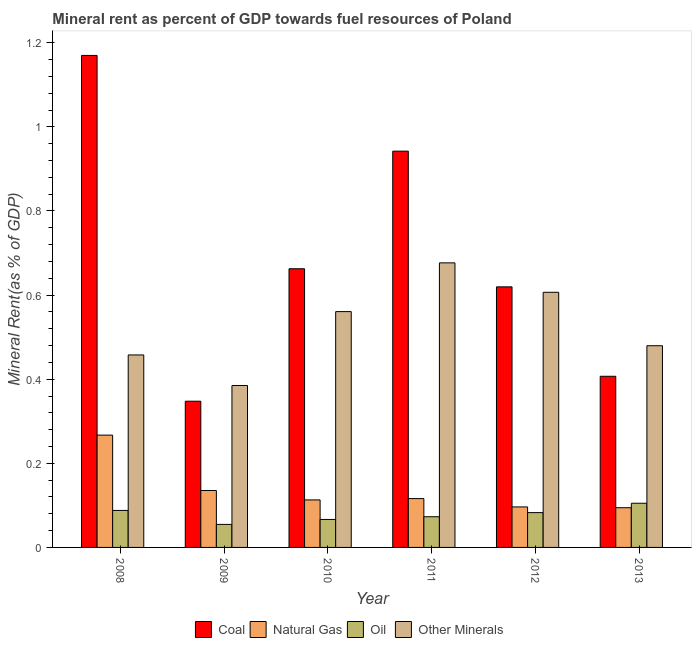How many groups of bars are there?
Provide a short and direct response. 6. Are the number of bars per tick equal to the number of legend labels?
Your answer should be very brief. Yes. What is the label of the 2nd group of bars from the left?
Ensure brevity in your answer.  2009. In how many cases, is the number of bars for a given year not equal to the number of legend labels?
Offer a very short reply. 0. What is the natural gas rent in 2009?
Make the answer very short. 0.14. Across all years, what is the maximum natural gas rent?
Keep it short and to the point. 0.27. Across all years, what is the minimum  rent of other minerals?
Provide a short and direct response. 0.39. In which year was the coal rent maximum?
Provide a short and direct response. 2008. In which year was the coal rent minimum?
Your answer should be very brief. 2009. What is the total coal rent in the graph?
Provide a short and direct response. 4.15. What is the difference between the natural gas rent in 2008 and that in 2010?
Provide a succinct answer. 0.15. What is the difference between the  rent of other minerals in 2008 and the oil rent in 2010?
Offer a terse response. -0.1. What is the average oil rent per year?
Provide a succinct answer. 0.08. In how many years, is the coal rent greater than 0.56 %?
Your answer should be compact. 4. What is the ratio of the natural gas rent in 2008 to that in 2012?
Give a very brief answer. 2.77. Is the difference between the oil rent in 2008 and 2013 greater than the difference between the coal rent in 2008 and 2013?
Offer a very short reply. No. What is the difference between the highest and the second highest  rent of other minerals?
Your answer should be very brief. 0.07. What is the difference between the highest and the lowest coal rent?
Provide a succinct answer. 0.82. What does the 4th bar from the left in 2013 represents?
Offer a very short reply. Other Minerals. What does the 4th bar from the right in 2013 represents?
Your answer should be very brief. Coal. Is it the case that in every year, the sum of the coal rent and natural gas rent is greater than the oil rent?
Keep it short and to the point. Yes. How many bars are there?
Make the answer very short. 24. Are all the bars in the graph horizontal?
Make the answer very short. No. Are the values on the major ticks of Y-axis written in scientific E-notation?
Your answer should be very brief. No. Does the graph contain any zero values?
Provide a succinct answer. No. Does the graph contain grids?
Keep it short and to the point. No. How many legend labels are there?
Your answer should be very brief. 4. What is the title of the graph?
Offer a terse response. Mineral rent as percent of GDP towards fuel resources of Poland. Does "Plant species" appear as one of the legend labels in the graph?
Provide a succinct answer. No. What is the label or title of the X-axis?
Ensure brevity in your answer.  Year. What is the label or title of the Y-axis?
Make the answer very short. Mineral Rent(as % of GDP). What is the Mineral Rent(as % of GDP) of Coal in 2008?
Your answer should be very brief. 1.17. What is the Mineral Rent(as % of GDP) of Natural Gas in 2008?
Ensure brevity in your answer.  0.27. What is the Mineral Rent(as % of GDP) in Oil in 2008?
Keep it short and to the point. 0.09. What is the Mineral Rent(as % of GDP) of Other Minerals in 2008?
Offer a very short reply. 0.46. What is the Mineral Rent(as % of GDP) of Coal in 2009?
Your answer should be compact. 0.35. What is the Mineral Rent(as % of GDP) of Natural Gas in 2009?
Ensure brevity in your answer.  0.14. What is the Mineral Rent(as % of GDP) of Oil in 2009?
Provide a succinct answer. 0.05. What is the Mineral Rent(as % of GDP) of Other Minerals in 2009?
Keep it short and to the point. 0.39. What is the Mineral Rent(as % of GDP) in Coal in 2010?
Your answer should be compact. 0.66. What is the Mineral Rent(as % of GDP) of Natural Gas in 2010?
Ensure brevity in your answer.  0.11. What is the Mineral Rent(as % of GDP) in Oil in 2010?
Provide a short and direct response. 0.07. What is the Mineral Rent(as % of GDP) of Other Minerals in 2010?
Your answer should be compact. 0.56. What is the Mineral Rent(as % of GDP) of Coal in 2011?
Ensure brevity in your answer.  0.94. What is the Mineral Rent(as % of GDP) in Natural Gas in 2011?
Provide a short and direct response. 0.12. What is the Mineral Rent(as % of GDP) in Oil in 2011?
Your response must be concise. 0.07. What is the Mineral Rent(as % of GDP) of Other Minerals in 2011?
Your answer should be very brief. 0.68. What is the Mineral Rent(as % of GDP) of Coal in 2012?
Your answer should be very brief. 0.62. What is the Mineral Rent(as % of GDP) of Natural Gas in 2012?
Your response must be concise. 0.1. What is the Mineral Rent(as % of GDP) in Oil in 2012?
Your response must be concise. 0.08. What is the Mineral Rent(as % of GDP) in Other Minerals in 2012?
Make the answer very short. 0.61. What is the Mineral Rent(as % of GDP) of Coal in 2013?
Offer a very short reply. 0.41. What is the Mineral Rent(as % of GDP) in Natural Gas in 2013?
Give a very brief answer. 0.09. What is the Mineral Rent(as % of GDP) in Oil in 2013?
Your answer should be very brief. 0.11. What is the Mineral Rent(as % of GDP) in Other Minerals in 2013?
Give a very brief answer. 0.48. Across all years, what is the maximum Mineral Rent(as % of GDP) in Coal?
Keep it short and to the point. 1.17. Across all years, what is the maximum Mineral Rent(as % of GDP) in Natural Gas?
Your answer should be compact. 0.27. Across all years, what is the maximum Mineral Rent(as % of GDP) in Oil?
Provide a short and direct response. 0.11. Across all years, what is the maximum Mineral Rent(as % of GDP) in Other Minerals?
Your answer should be compact. 0.68. Across all years, what is the minimum Mineral Rent(as % of GDP) in Coal?
Ensure brevity in your answer.  0.35. Across all years, what is the minimum Mineral Rent(as % of GDP) in Natural Gas?
Ensure brevity in your answer.  0.09. Across all years, what is the minimum Mineral Rent(as % of GDP) of Oil?
Make the answer very short. 0.05. Across all years, what is the minimum Mineral Rent(as % of GDP) of Other Minerals?
Provide a succinct answer. 0.39. What is the total Mineral Rent(as % of GDP) in Coal in the graph?
Ensure brevity in your answer.  4.15. What is the total Mineral Rent(as % of GDP) in Natural Gas in the graph?
Provide a short and direct response. 0.82. What is the total Mineral Rent(as % of GDP) in Oil in the graph?
Your answer should be very brief. 0.47. What is the total Mineral Rent(as % of GDP) of Other Minerals in the graph?
Provide a succinct answer. 3.17. What is the difference between the Mineral Rent(as % of GDP) in Coal in 2008 and that in 2009?
Your answer should be compact. 0.82. What is the difference between the Mineral Rent(as % of GDP) of Natural Gas in 2008 and that in 2009?
Offer a terse response. 0.13. What is the difference between the Mineral Rent(as % of GDP) of Oil in 2008 and that in 2009?
Your answer should be very brief. 0.03. What is the difference between the Mineral Rent(as % of GDP) in Other Minerals in 2008 and that in 2009?
Ensure brevity in your answer.  0.07. What is the difference between the Mineral Rent(as % of GDP) in Coal in 2008 and that in 2010?
Ensure brevity in your answer.  0.51. What is the difference between the Mineral Rent(as % of GDP) of Natural Gas in 2008 and that in 2010?
Your response must be concise. 0.15. What is the difference between the Mineral Rent(as % of GDP) of Oil in 2008 and that in 2010?
Offer a very short reply. 0.02. What is the difference between the Mineral Rent(as % of GDP) in Other Minerals in 2008 and that in 2010?
Offer a very short reply. -0.1. What is the difference between the Mineral Rent(as % of GDP) in Coal in 2008 and that in 2011?
Your answer should be very brief. 0.23. What is the difference between the Mineral Rent(as % of GDP) of Natural Gas in 2008 and that in 2011?
Make the answer very short. 0.15. What is the difference between the Mineral Rent(as % of GDP) in Oil in 2008 and that in 2011?
Your answer should be compact. 0.01. What is the difference between the Mineral Rent(as % of GDP) of Other Minerals in 2008 and that in 2011?
Your response must be concise. -0.22. What is the difference between the Mineral Rent(as % of GDP) of Coal in 2008 and that in 2012?
Your response must be concise. 0.55. What is the difference between the Mineral Rent(as % of GDP) in Natural Gas in 2008 and that in 2012?
Your answer should be very brief. 0.17. What is the difference between the Mineral Rent(as % of GDP) of Oil in 2008 and that in 2012?
Offer a terse response. 0.01. What is the difference between the Mineral Rent(as % of GDP) in Other Minerals in 2008 and that in 2012?
Provide a short and direct response. -0.15. What is the difference between the Mineral Rent(as % of GDP) of Coal in 2008 and that in 2013?
Your answer should be compact. 0.76. What is the difference between the Mineral Rent(as % of GDP) of Natural Gas in 2008 and that in 2013?
Your answer should be compact. 0.17. What is the difference between the Mineral Rent(as % of GDP) in Oil in 2008 and that in 2013?
Provide a succinct answer. -0.02. What is the difference between the Mineral Rent(as % of GDP) in Other Minerals in 2008 and that in 2013?
Keep it short and to the point. -0.02. What is the difference between the Mineral Rent(as % of GDP) in Coal in 2009 and that in 2010?
Offer a very short reply. -0.32. What is the difference between the Mineral Rent(as % of GDP) of Natural Gas in 2009 and that in 2010?
Your response must be concise. 0.02. What is the difference between the Mineral Rent(as % of GDP) in Oil in 2009 and that in 2010?
Give a very brief answer. -0.01. What is the difference between the Mineral Rent(as % of GDP) in Other Minerals in 2009 and that in 2010?
Your answer should be compact. -0.18. What is the difference between the Mineral Rent(as % of GDP) of Coal in 2009 and that in 2011?
Your answer should be very brief. -0.59. What is the difference between the Mineral Rent(as % of GDP) in Natural Gas in 2009 and that in 2011?
Provide a short and direct response. 0.02. What is the difference between the Mineral Rent(as % of GDP) in Oil in 2009 and that in 2011?
Ensure brevity in your answer.  -0.02. What is the difference between the Mineral Rent(as % of GDP) of Other Minerals in 2009 and that in 2011?
Ensure brevity in your answer.  -0.29. What is the difference between the Mineral Rent(as % of GDP) in Coal in 2009 and that in 2012?
Your answer should be compact. -0.27. What is the difference between the Mineral Rent(as % of GDP) in Natural Gas in 2009 and that in 2012?
Your response must be concise. 0.04. What is the difference between the Mineral Rent(as % of GDP) in Oil in 2009 and that in 2012?
Give a very brief answer. -0.03. What is the difference between the Mineral Rent(as % of GDP) in Other Minerals in 2009 and that in 2012?
Offer a terse response. -0.22. What is the difference between the Mineral Rent(as % of GDP) in Coal in 2009 and that in 2013?
Offer a very short reply. -0.06. What is the difference between the Mineral Rent(as % of GDP) of Natural Gas in 2009 and that in 2013?
Ensure brevity in your answer.  0.04. What is the difference between the Mineral Rent(as % of GDP) in Oil in 2009 and that in 2013?
Make the answer very short. -0.05. What is the difference between the Mineral Rent(as % of GDP) of Other Minerals in 2009 and that in 2013?
Provide a succinct answer. -0.09. What is the difference between the Mineral Rent(as % of GDP) of Coal in 2010 and that in 2011?
Your answer should be very brief. -0.28. What is the difference between the Mineral Rent(as % of GDP) in Natural Gas in 2010 and that in 2011?
Offer a very short reply. -0. What is the difference between the Mineral Rent(as % of GDP) in Oil in 2010 and that in 2011?
Offer a terse response. -0.01. What is the difference between the Mineral Rent(as % of GDP) in Other Minerals in 2010 and that in 2011?
Your answer should be compact. -0.12. What is the difference between the Mineral Rent(as % of GDP) in Coal in 2010 and that in 2012?
Provide a succinct answer. 0.04. What is the difference between the Mineral Rent(as % of GDP) in Natural Gas in 2010 and that in 2012?
Provide a short and direct response. 0.02. What is the difference between the Mineral Rent(as % of GDP) of Oil in 2010 and that in 2012?
Keep it short and to the point. -0.02. What is the difference between the Mineral Rent(as % of GDP) in Other Minerals in 2010 and that in 2012?
Your answer should be compact. -0.05. What is the difference between the Mineral Rent(as % of GDP) of Coal in 2010 and that in 2013?
Provide a short and direct response. 0.26. What is the difference between the Mineral Rent(as % of GDP) of Natural Gas in 2010 and that in 2013?
Ensure brevity in your answer.  0.02. What is the difference between the Mineral Rent(as % of GDP) in Oil in 2010 and that in 2013?
Keep it short and to the point. -0.04. What is the difference between the Mineral Rent(as % of GDP) in Other Minerals in 2010 and that in 2013?
Your response must be concise. 0.08. What is the difference between the Mineral Rent(as % of GDP) of Coal in 2011 and that in 2012?
Your response must be concise. 0.32. What is the difference between the Mineral Rent(as % of GDP) of Natural Gas in 2011 and that in 2012?
Give a very brief answer. 0.02. What is the difference between the Mineral Rent(as % of GDP) in Oil in 2011 and that in 2012?
Offer a very short reply. -0.01. What is the difference between the Mineral Rent(as % of GDP) of Other Minerals in 2011 and that in 2012?
Your answer should be compact. 0.07. What is the difference between the Mineral Rent(as % of GDP) of Coal in 2011 and that in 2013?
Ensure brevity in your answer.  0.54. What is the difference between the Mineral Rent(as % of GDP) of Natural Gas in 2011 and that in 2013?
Provide a short and direct response. 0.02. What is the difference between the Mineral Rent(as % of GDP) in Oil in 2011 and that in 2013?
Your answer should be compact. -0.03. What is the difference between the Mineral Rent(as % of GDP) in Other Minerals in 2011 and that in 2013?
Keep it short and to the point. 0.2. What is the difference between the Mineral Rent(as % of GDP) in Coal in 2012 and that in 2013?
Provide a short and direct response. 0.21. What is the difference between the Mineral Rent(as % of GDP) in Natural Gas in 2012 and that in 2013?
Make the answer very short. 0. What is the difference between the Mineral Rent(as % of GDP) of Oil in 2012 and that in 2013?
Give a very brief answer. -0.02. What is the difference between the Mineral Rent(as % of GDP) of Other Minerals in 2012 and that in 2013?
Ensure brevity in your answer.  0.13. What is the difference between the Mineral Rent(as % of GDP) in Coal in 2008 and the Mineral Rent(as % of GDP) in Natural Gas in 2009?
Your answer should be compact. 1.03. What is the difference between the Mineral Rent(as % of GDP) in Coal in 2008 and the Mineral Rent(as % of GDP) in Oil in 2009?
Your answer should be very brief. 1.12. What is the difference between the Mineral Rent(as % of GDP) of Coal in 2008 and the Mineral Rent(as % of GDP) of Other Minerals in 2009?
Your answer should be very brief. 0.78. What is the difference between the Mineral Rent(as % of GDP) of Natural Gas in 2008 and the Mineral Rent(as % of GDP) of Oil in 2009?
Your answer should be very brief. 0.21. What is the difference between the Mineral Rent(as % of GDP) of Natural Gas in 2008 and the Mineral Rent(as % of GDP) of Other Minerals in 2009?
Your answer should be compact. -0.12. What is the difference between the Mineral Rent(as % of GDP) of Oil in 2008 and the Mineral Rent(as % of GDP) of Other Minerals in 2009?
Your answer should be very brief. -0.3. What is the difference between the Mineral Rent(as % of GDP) in Coal in 2008 and the Mineral Rent(as % of GDP) in Natural Gas in 2010?
Provide a short and direct response. 1.06. What is the difference between the Mineral Rent(as % of GDP) in Coal in 2008 and the Mineral Rent(as % of GDP) in Oil in 2010?
Your answer should be very brief. 1.1. What is the difference between the Mineral Rent(as % of GDP) of Coal in 2008 and the Mineral Rent(as % of GDP) of Other Minerals in 2010?
Your answer should be very brief. 0.61. What is the difference between the Mineral Rent(as % of GDP) of Natural Gas in 2008 and the Mineral Rent(as % of GDP) of Oil in 2010?
Give a very brief answer. 0.2. What is the difference between the Mineral Rent(as % of GDP) in Natural Gas in 2008 and the Mineral Rent(as % of GDP) in Other Minerals in 2010?
Offer a terse response. -0.29. What is the difference between the Mineral Rent(as % of GDP) of Oil in 2008 and the Mineral Rent(as % of GDP) of Other Minerals in 2010?
Ensure brevity in your answer.  -0.47. What is the difference between the Mineral Rent(as % of GDP) in Coal in 2008 and the Mineral Rent(as % of GDP) in Natural Gas in 2011?
Provide a short and direct response. 1.05. What is the difference between the Mineral Rent(as % of GDP) of Coal in 2008 and the Mineral Rent(as % of GDP) of Oil in 2011?
Ensure brevity in your answer.  1.1. What is the difference between the Mineral Rent(as % of GDP) in Coal in 2008 and the Mineral Rent(as % of GDP) in Other Minerals in 2011?
Your answer should be compact. 0.49. What is the difference between the Mineral Rent(as % of GDP) in Natural Gas in 2008 and the Mineral Rent(as % of GDP) in Oil in 2011?
Your response must be concise. 0.19. What is the difference between the Mineral Rent(as % of GDP) of Natural Gas in 2008 and the Mineral Rent(as % of GDP) of Other Minerals in 2011?
Offer a very short reply. -0.41. What is the difference between the Mineral Rent(as % of GDP) of Oil in 2008 and the Mineral Rent(as % of GDP) of Other Minerals in 2011?
Provide a short and direct response. -0.59. What is the difference between the Mineral Rent(as % of GDP) of Coal in 2008 and the Mineral Rent(as % of GDP) of Natural Gas in 2012?
Make the answer very short. 1.07. What is the difference between the Mineral Rent(as % of GDP) in Coal in 2008 and the Mineral Rent(as % of GDP) in Oil in 2012?
Make the answer very short. 1.09. What is the difference between the Mineral Rent(as % of GDP) of Coal in 2008 and the Mineral Rent(as % of GDP) of Other Minerals in 2012?
Your answer should be very brief. 0.56. What is the difference between the Mineral Rent(as % of GDP) in Natural Gas in 2008 and the Mineral Rent(as % of GDP) in Oil in 2012?
Your response must be concise. 0.18. What is the difference between the Mineral Rent(as % of GDP) of Natural Gas in 2008 and the Mineral Rent(as % of GDP) of Other Minerals in 2012?
Your answer should be very brief. -0.34. What is the difference between the Mineral Rent(as % of GDP) of Oil in 2008 and the Mineral Rent(as % of GDP) of Other Minerals in 2012?
Keep it short and to the point. -0.52. What is the difference between the Mineral Rent(as % of GDP) of Coal in 2008 and the Mineral Rent(as % of GDP) of Natural Gas in 2013?
Offer a terse response. 1.08. What is the difference between the Mineral Rent(as % of GDP) of Coal in 2008 and the Mineral Rent(as % of GDP) of Oil in 2013?
Ensure brevity in your answer.  1.06. What is the difference between the Mineral Rent(as % of GDP) in Coal in 2008 and the Mineral Rent(as % of GDP) in Other Minerals in 2013?
Offer a very short reply. 0.69. What is the difference between the Mineral Rent(as % of GDP) of Natural Gas in 2008 and the Mineral Rent(as % of GDP) of Oil in 2013?
Provide a succinct answer. 0.16. What is the difference between the Mineral Rent(as % of GDP) in Natural Gas in 2008 and the Mineral Rent(as % of GDP) in Other Minerals in 2013?
Keep it short and to the point. -0.21. What is the difference between the Mineral Rent(as % of GDP) in Oil in 2008 and the Mineral Rent(as % of GDP) in Other Minerals in 2013?
Your response must be concise. -0.39. What is the difference between the Mineral Rent(as % of GDP) in Coal in 2009 and the Mineral Rent(as % of GDP) in Natural Gas in 2010?
Your answer should be very brief. 0.23. What is the difference between the Mineral Rent(as % of GDP) of Coal in 2009 and the Mineral Rent(as % of GDP) of Oil in 2010?
Your answer should be very brief. 0.28. What is the difference between the Mineral Rent(as % of GDP) in Coal in 2009 and the Mineral Rent(as % of GDP) in Other Minerals in 2010?
Your response must be concise. -0.21. What is the difference between the Mineral Rent(as % of GDP) of Natural Gas in 2009 and the Mineral Rent(as % of GDP) of Oil in 2010?
Make the answer very short. 0.07. What is the difference between the Mineral Rent(as % of GDP) in Natural Gas in 2009 and the Mineral Rent(as % of GDP) in Other Minerals in 2010?
Ensure brevity in your answer.  -0.43. What is the difference between the Mineral Rent(as % of GDP) in Oil in 2009 and the Mineral Rent(as % of GDP) in Other Minerals in 2010?
Keep it short and to the point. -0.51. What is the difference between the Mineral Rent(as % of GDP) of Coal in 2009 and the Mineral Rent(as % of GDP) of Natural Gas in 2011?
Your answer should be compact. 0.23. What is the difference between the Mineral Rent(as % of GDP) of Coal in 2009 and the Mineral Rent(as % of GDP) of Oil in 2011?
Give a very brief answer. 0.27. What is the difference between the Mineral Rent(as % of GDP) in Coal in 2009 and the Mineral Rent(as % of GDP) in Other Minerals in 2011?
Provide a short and direct response. -0.33. What is the difference between the Mineral Rent(as % of GDP) of Natural Gas in 2009 and the Mineral Rent(as % of GDP) of Oil in 2011?
Provide a succinct answer. 0.06. What is the difference between the Mineral Rent(as % of GDP) in Natural Gas in 2009 and the Mineral Rent(as % of GDP) in Other Minerals in 2011?
Your response must be concise. -0.54. What is the difference between the Mineral Rent(as % of GDP) in Oil in 2009 and the Mineral Rent(as % of GDP) in Other Minerals in 2011?
Make the answer very short. -0.62. What is the difference between the Mineral Rent(as % of GDP) of Coal in 2009 and the Mineral Rent(as % of GDP) of Natural Gas in 2012?
Ensure brevity in your answer.  0.25. What is the difference between the Mineral Rent(as % of GDP) in Coal in 2009 and the Mineral Rent(as % of GDP) in Oil in 2012?
Provide a short and direct response. 0.26. What is the difference between the Mineral Rent(as % of GDP) of Coal in 2009 and the Mineral Rent(as % of GDP) of Other Minerals in 2012?
Your answer should be compact. -0.26. What is the difference between the Mineral Rent(as % of GDP) of Natural Gas in 2009 and the Mineral Rent(as % of GDP) of Oil in 2012?
Make the answer very short. 0.05. What is the difference between the Mineral Rent(as % of GDP) of Natural Gas in 2009 and the Mineral Rent(as % of GDP) of Other Minerals in 2012?
Keep it short and to the point. -0.47. What is the difference between the Mineral Rent(as % of GDP) of Oil in 2009 and the Mineral Rent(as % of GDP) of Other Minerals in 2012?
Make the answer very short. -0.55. What is the difference between the Mineral Rent(as % of GDP) of Coal in 2009 and the Mineral Rent(as % of GDP) of Natural Gas in 2013?
Provide a short and direct response. 0.25. What is the difference between the Mineral Rent(as % of GDP) of Coal in 2009 and the Mineral Rent(as % of GDP) of Oil in 2013?
Provide a short and direct response. 0.24. What is the difference between the Mineral Rent(as % of GDP) of Coal in 2009 and the Mineral Rent(as % of GDP) of Other Minerals in 2013?
Give a very brief answer. -0.13. What is the difference between the Mineral Rent(as % of GDP) in Natural Gas in 2009 and the Mineral Rent(as % of GDP) in Oil in 2013?
Provide a succinct answer. 0.03. What is the difference between the Mineral Rent(as % of GDP) of Natural Gas in 2009 and the Mineral Rent(as % of GDP) of Other Minerals in 2013?
Your answer should be compact. -0.34. What is the difference between the Mineral Rent(as % of GDP) of Oil in 2009 and the Mineral Rent(as % of GDP) of Other Minerals in 2013?
Make the answer very short. -0.42. What is the difference between the Mineral Rent(as % of GDP) in Coal in 2010 and the Mineral Rent(as % of GDP) in Natural Gas in 2011?
Offer a terse response. 0.55. What is the difference between the Mineral Rent(as % of GDP) in Coal in 2010 and the Mineral Rent(as % of GDP) in Oil in 2011?
Provide a short and direct response. 0.59. What is the difference between the Mineral Rent(as % of GDP) of Coal in 2010 and the Mineral Rent(as % of GDP) of Other Minerals in 2011?
Offer a terse response. -0.01. What is the difference between the Mineral Rent(as % of GDP) in Natural Gas in 2010 and the Mineral Rent(as % of GDP) in Oil in 2011?
Ensure brevity in your answer.  0.04. What is the difference between the Mineral Rent(as % of GDP) of Natural Gas in 2010 and the Mineral Rent(as % of GDP) of Other Minerals in 2011?
Provide a succinct answer. -0.56. What is the difference between the Mineral Rent(as % of GDP) of Oil in 2010 and the Mineral Rent(as % of GDP) of Other Minerals in 2011?
Offer a terse response. -0.61. What is the difference between the Mineral Rent(as % of GDP) in Coal in 2010 and the Mineral Rent(as % of GDP) in Natural Gas in 2012?
Your response must be concise. 0.57. What is the difference between the Mineral Rent(as % of GDP) of Coal in 2010 and the Mineral Rent(as % of GDP) of Oil in 2012?
Provide a succinct answer. 0.58. What is the difference between the Mineral Rent(as % of GDP) in Coal in 2010 and the Mineral Rent(as % of GDP) in Other Minerals in 2012?
Offer a very short reply. 0.06. What is the difference between the Mineral Rent(as % of GDP) of Natural Gas in 2010 and the Mineral Rent(as % of GDP) of Oil in 2012?
Your response must be concise. 0.03. What is the difference between the Mineral Rent(as % of GDP) in Natural Gas in 2010 and the Mineral Rent(as % of GDP) in Other Minerals in 2012?
Provide a succinct answer. -0.49. What is the difference between the Mineral Rent(as % of GDP) of Oil in 2010 and the Mineral Rent(as % of GDP) of Other Minerals in 2012?
Offer a very short reply. -0.54. What is the difference between the Mineral Rent(as % of GDP) in Coal in 2010 and the Mineral Rent(as % of GDP) in Natural Gas in 2013?
Your answer should be compact. 0.57. What is the difference between the Mineral Rent(as % of GDP) of Coal in 2010 and the Mineral Rent(as % of GDP) of Oil in 2013?
Keep it short and to the point. 0.56. What is the difference between the Mineral Rent(as % of GDP) of Coal in 2010 and the Mineral Rent(as % of GDP) of Other Minerals in 2013?
Give a very brief answer. 0.18. What is the difference between the Mineral Rent(as % of GDP) of Natural Gas in 2010 and the Mineral Rent(as % of GDP) of Oil in 2013?
Offer a very short reply. 0.01. What is the difference between the Mineral Rent(as % of GDP) of Natural Gas in 2010 and the Mineral Rent(as % of GDP) of Other Minerals in 2013?
Provide a short and direct response. -0.37. What is the difference between the Mineral Rent(as % of GDP) in Oil in 2010 and the Mineral Rent(as % of GDP) in Other Minerals in 2013?
Your answer should be compact. -0.41. What is the difference between the Mineral Rent(as % of GDP) in Coal in 2011 and the Mineral Rent(as % of GDP) in Natural Gas in 2012?
Your answer should be very brief. 0.85. What is the difference between the Mineral Rent(as % of GDP) of Coal in 2011 and the Mineral Rent(as % of GDP) of Oil in 2012?
Keep it short and to the point. 0.86. What is the difference between the Mineral Rent(as % of GDP) in Coal in 2011 and the Mineral Rent(as % of GDP) in Other Minerals in 2012?
Your answer should be compact. 0.34. What is the difference between the Mineral Rent(as % of GDP) of Natural Gas in 2011 and the Mineral Rent(as % of GDP) of Oil in 2012?
Provide a succinct answer. 0.03. What is the difference between the Mineral Rent(as % of GDP) in Natural Gas in 2011 and the Mineral Rent(as % of GDP) in Other Minerals in 2012?
Offer a very short reply. -0.49. What is the difference between the Mineral Rent(as % of GDP) in Oil in 2011 and the Mineral Rent(as % of GDP) in Other Minerals in 2012?
Ensure brevity in your answer.  -0.53. What is the difference between the Mineral Rent(as % of GDP) in Coal in 2011 and the Mineral Rent(as % of GDP) in Natural Gas in 2013?
Your response must be concise. 0.85. What is the difference between the Mineral Rent(as % of GDP) in Coal in 2011 and the Mineral Rent(as % of GDP) in Oil in 2013?
Ensure brevity in your answer.  0.84. What is the difference between the Mineral Rent(as % of GDP) in Coal in 2011 and the Mineral Rent(as % of GDP) in Other Minerals in 2013?
Your answer should be very brief. 0.46. What is the difference between the Mineral Rent(as % of GDP) in Natural Gas in 2011 and the Mineral Rent(as % of GDP) in Oil in 2013?
Your answer should be very brief. 0.01. What is the difference between the Mineral Rent(as % of GDP) of Natural Gas in 2011 and the Mineral Rent(as % of GDP) of Other Minerals in 2013?
Keep it short and to the point. -0.36. What is the difference between the Mineral Rent(as % of GDP) of Oil in 2011 and the Mineral Rent(as % of GDP) of Other Minerals in 2013?
Keep it short and to the point. -0.41. What is the difference between the Mineral Rent(as % of GDP) in Coal in 2012 and the Mineral Rent(as % of GDP) in Natural Gas in 2013?
Provide a short and direct response. 0.53. What is the difference between the Mineral Rent(as % of GDP) of Coal in 2012 and the Mineral Rent(as % of GDP) of Oil in 2013?
Make the answer very short. 0.51. What is the difference between the Mineral Rent(as % of GDP) of Coal in 2012 and the Mineral Rent(as % of GDP) of Other Minerals in 2013?
Offer a terse response. 0.14. What is the difference between the Mineral Rent(as % of GDP) in Natural Gas in 2012 and the Mineral Rent(as % of GDP) in Oil in 2013?
Provide a succinct answer. -0.01. What is the difference between the Mineral Rent(as % of GDP) of Natural Gas in 2012 and the Mineral Rent(as % of GDP) of Other Minerals in 2013?
Provide a short and direct response. -0.38. What is the difference between the Mineral Rent(as % of GDP) of Oil in 2012 and the Mineral Rent(as % of GDP) of Other Minerals in 2013?
Offer a terse response. -0.4. What is the average Mineral Rent(as % of GDP) in Coal per year?
Offer a very short reply. 0.69. What is the average Mineral Rent(as % of GDP) in Natural Gas per year?
Offer a very short reply. 0.14. What is the average Mineral Rent(as % of GDP) of Oil per year?
Give a very brief answer. 0.08. What is the average Mineral Rent(as % of GDP) in Other Minerals per year?
Provide a short and direct response. 0.53. In the year 2008, what is the difference between the Mineral Rent(as % of GDP) of Coal and Mineral Rent(as % of GDP) of Natural Gas?
Keep it short and to the point. 0.9. In the year 2008, what is the difference between the Mineral Rent(as % of GDP) in Coal and Mineral Rent(as % of GDP) in Oil?
Offer a very short reply. 1.08. In the year 2008, what is the difference between the Mineral Rent(as % of GDP) of Coal and Mineral Rent(as % of GDP) of Other Minerals?
Keep it short and to the point. 0.71. In the year 2008, what is the difference between the Mineral Rent(as % of GDP) in Natural Gas and Mineral Rent(as % of GDP) in Oil?
Provide a short and direct response. 0.18. In the year 2008, what is the difference between the Mineral Rent(as % of GDP) of Natural Gas and Mineral Rent(as % of GDP) of Other Minerals?
Provide a short and direct response. -0.19. In the year 2008, what is the difference between the Mineral Rent(as % of GDP) of Oil and Mineral Rent(as % of GDP) of Other Minerals?
Provide a succinct answer. -0.37. In the year 2009, what is the difference between the Mineral Rent(as % of GDP) of Coal and Mineral Rent(as % of GDP) of Natural Gas?
Your answer should be very brief. 0.21. In the year 2009, what is the difference between the Mineral Rent(as % of GDP) in Coal and Mineral Rent(as % of GDP) in Oil?
Ensure brevity in your answer.  0.29. In the year 2009, what is the difference between the Mineral Rent(as % of GDP) in Coal and Mineral Rent(as % of GDP) in Other Minerals?
Provide a short and direct response. -0.04. In the year 2009, what is the difference between the Mineral Rent(as % of GDP) in Natural Gas and Mineral Rent(as % of GDP) in Oil?
Provide a succinct answer. 0.08. In the year 2009, what is the difference between the Mineral Rent(as % of GDP) of Natural Gas and Mineral Rent(as % of GDP) of Other Minerals?
Offer a terse response. -0.25. In the year 2009, what is the difference between the Mineral Rent(as % of GDP) in Oil and Mineral Rent(as % of GDP) in Other Minerals?
Offer a very short reply. -0.33. In the year 2010, what is the difference between the Mineral Rent(as % of GDP) in Coal and Mineral Rent(as % of GDP) in Natural Gas?
Your answer should be very brief. 0.55. In the year 2010, what is the difference between the Mineral Rent(as % of GDP) of Coal and Mineral Rent(as % of GDP) of Oil?
Offer a very short reply. 0.6. In the year 2010, what is the difference between the Mineral Rent(as % of GDP) in Coal and Mineral Rent(as % of GDP) in Other Minerals?
Offer a very short reply. 0.1. In the year 2010, what is the difference between the Mineral Rent(as % of GDP) in Natural Gas and Mineral Rent(as % of GDP) in Oil?
Keep it short and to the point. 0.05. In the year 2010, what is the difference between the Mineral Rent(as % of GDP) in Natural Gas and Mineral Rent(as % of GDP) in Other Minerals?
Your response must be concise. -0.45. In the year 2010, what is the difference between the Mineral Rent(as % of GDP) in Oil and Mineral Rent(as % of GDP) in Other Minerals?
Give a very brief answer. -0.49. In the year 2011, what is the difference between the Mineral Rent(as % of GDP) of Coal and Mineral Rent(as % of GDP) of Natural Gas?
Your answer should be compact. 0.83. In the year 2011, what is the difference between the Mineral Rent(as % of GDP) of Coal and Mineral Rent(as % of GDP) of Oil?
Provide a short and direct response. 0.87. In the year 2011, what is the difference between the Mineral Rent(as % of GDP) in Coal and Mineral Rent(as % of GDP) in Other Minerals?
Offer a very short reply. 0.27. In the year 2011, what is the difference between the Mineral Rent(as % of GDP) of Natural Gas and Mineral Rent(as % of GDP) of Oil?
Your answer should be very brief. 0.04. In the year 2011, what is the difference between the Mineral Rent(as % of GDP) in Natural Gas and Mineral Rent(as % of GDP) in Other Minerals?
Your response must be concise. -0.56. In the year 2011, what is the difference between the Mineral Rent(as % of GDP) of Oil and Mineral Rent(as % of GDP) of Other Minerals?
Provide a succinct answer. -0.6. In the year 2012, what is the difference between the Mineral Rent(as % of GDP) in Coal and Mineral Rent(as % of GDP) in Natural Gas?
Your answer should be compact. 0.52. In the year 2012, what is the difference between the Mineral Rent(as % of GDP) in Coal and Mineral Rent(as % of GDP) in Oil?
Ensure brevity in your answer.  0.54. In the year 2012, what is the difference between the Mineral Rent(as % of GDP) in Coal and Mineral Rent(as % of GDP) in Other Minerals?
Keep it short and to the point. 0.01. In the year 2012, what is the difference between the Mineral Rent(as % of GDP) of Natural Gas and Mineral Rent(as % of GDP) of Oil?
Make the answer very short. 0.01. In the year 2012, what is the difference between the Mineral Rent(as % of GDP) in Natural Gas and Mineral Rent(as % of GDP) in Other Minerals?
Your answer should be very brief. -0.51. In the year 2012, what is the difference between the Mineral Rent(as % of GDP) of Oil and Mineral Rent(as % of GDP) of Other Minerals?
Keep it short and to the point. -0.52. In the year 2013, what is the difference between the Mineral Rent(as % of GDP) of Coal and Mineral Rent(as % of GDP) of Natural Gas?
Provide a succinct answer. 0.31. In the year 2013, what is the difference between the Mineral Rent(as % of GDP) of Coal and Mineral Rent(as % of GDP) of Oil?
Your answer should be compact. 0.3. In the year 2013, what is the difference between the Mineral Rent(as % of GDP) in Coal and Mineral Rent(as % of GDP) in Other Minerals?
Your response must be concise. -0.07. In the year 2013, what is the difference between the Mineral Rent(as % of GDP) in Natural Gas and Mineral Rent(as % of GDP) in Oil?
Your answer should be very brief. -0.01. In the year 2013, what is the difference between the Mineral Rent(as % of GDP) of Natural Gas and Mineral Rent(as % of GDP) of Other Minerals?
Give a very brief answer. -0.39. In the year 2013, what is the difference between the Mineral Rent(as % of GDP) of Oil and Mineral Rent(as % of GDP) of Other Minerals?
Give a very brief answer. -0.37. What is the ratio of the Mineral Rent(as % of GDP) of Coal in 2008 to that in 2009?
Offer a terse response. 3.36. What is the ratio of the Mineral Rent(as % of GDP) in Natural Gas in 2008 to that in 2009?
Offer a terse response. 1.97. What is the ratio of the Mineral Rent(as % of GDP) of Oil in 2008 to that in 2009?
Your response must be concise. 1.61. What is the ratio of the Mineral Rent(as % of GDP) of Other Minerals in 2008 to that in 2009?
Your response must be concise. 1.19. What is the ratio of the Mineral Rent(as % of GDP) in Coal in 2008 to that in 2010?
Provide a short and direct response. 1.77. What is the ratio of the Mineral Rent(as % of GDP) in Natural Gas in 2008 to that in 2010?
Offer a terse response. 2.36. What is the ratio of the Mineral Rent(as % of GDP) of Oil in 2008 to that in 2010?
Offer a terse response. 1.32. What is the ratio of the Mineral Rent(as % of GDP) in Other Minerals in 2008 to that in 2010?
Provide a succinct answer. 0.82. What is the ratio of the Mineral Rent(as % of GDP) of Coal in 2008 to that in 2011?
Provide a succinct answer. 1.24. What is the ratio of the Mineral Rent(as % of GDP) of Natural Gas in 2008 to that in 2011?
Your answer should be compact. 2.3. What is the ratio of the Mineral Rent(as % of GDP) in Oil in 2008 to that in 2011?
Provide a short and direct response. 1.21. What is the ratio of the Mineral Rent(as % of GDP) of Other Minerals in 2008 to that in 2011?
Provide a succinct answer. 0.68. What is the ratio of the Mineral Rent(as % of GDP) in Coal in 2008 to that in 2012?
Offer a terse response. 1.89. What is the ratio of the Mineral Rent(as % of GDP) of Natural Gas in 2008 to that in 2012?
Offer a very short reply. 2.77. What is the ratio of the Mineral Rent(as % of GDP) of Oil in 2008 to that in 2012?
Your answer should be very brief. 1.06. What is the ratio of the Mineral Rent(as % of GDP) of Other Minerals in 2008 to that in 2012?
Keep it short and to the point. 0.75. What is the ratio of the Mineral Rent(as % of GDP) of Coal in 2008 to that in 2013?
Your response must be concise. 2.87. What is the ratio of the Mineral Rent(as % of GDP) of Natural Gas in 2008 to that in 2013?
Give a very brief answer. 2.83. What is the ratio of the Mineral Rent(as % of GDP) of Oil in 2008 to that in 2013?
Your answer should be very brief. 0.84. What is the ratio of the Mineral Rent(as % of GDP) in Other Minerals in 2008 to that in 2013?
Provide a succinct answer. 0.95. What is the ratio of the Mineral Rent(as % of GDP) in Coal in 2009 to that in 2010?
Give a very brief answer. 0.52. What is the ratio of the Mineral Rent(as % of GDP) of Natural Gas in 2009 to that in 2010?
Your answer should be compact. 1.2. What is the ratio of the Mineral Rent(as % of GDP) of Oil in 2009 to that in 2010?
Ensure brevity in your answer.  0.82. What is the ratio of the Mineral Rent(as % of GDP) in Other Minerals in 2009 to that in 2010?
Your answer should be compact. 0.69. What is the ratio of the Mineral Rent(as % of GDP) of Coal in 2009 to that in 2011?
Your answer should be compact. 0.37. What is the ratio of the Mineral Rent(as % of GDP) in Natural Gas in 2009 to that in 2011?
Provide a short and direct response. 1.17. What is the ratio of the Mineral Rent(as % of GDP) in Oil in 2009 to that in 2011?
Your answer should be compact. 0.75. What is the ratio of the Mineral Rent(as % of GDP) of Other Minerals in 2009 to that in 2011?
Your response must be concise. 0.57. What is the ratio of the Mineral Rent(as % of GDP) in Coal in 2009 to that in 2012?
Your answer should be compact. 0.56. What is the ratio of the Mineral Rent(as % of GDP) in Natural Gas in 2009 to that in 2012?
Provide a short and direct response. 1.41. What is the ratio of the Mineral Rent(as % of GDP) of Oil in 2009 to that in 2012?
Make the answer very short. 0.66. What is the ratio of the Mineral Rent(as % of GDP) in Other Minerals in 2009 to that in 2012?
Make the answer very short. 0.63. What is the ratio of the Mineral Rent(as % of GDP) of Coal in 2009 to that in 2013?
Provide a short and direct response. 0.85. What is the ratio of the Mineral Rent(as % of GDP) of Natural Gas in 2009 to that in 2013?
Provide a short and direct response. 1.43. What is the ratio of the Mineral Rent(as % of GDP) of Oil in 2009 to that in 2013?
Provide a short and direct response. 0.52. What is the ratio of the Mineral Rent(as % of GDP) in Other Minerals in 2009 to that in 2013?
Your answer should be compact. 0.8. What is the ratio of the Mineral Rent(as % of GDP) in Coal in 2010 to that in 2011?
Make the answer very short. 0.7. What is the ratio of the Mineral Rent(as % of GDP) of Natural Gas in 2010 to that in 2011?
Give a very brief answer. 0.97. What is the ratio of the Mineral Rent(as % of GDP) in Oil in 2010 to that in 2011?
Make the answer very short. 0.91. What is the ratio of the Mineral Rent(as % of GDP) in Other Minerals in 2010 to that in 2011?
Make the answer very short. 0.83. What is the ratio of the Mineral Rent(as % of GDP) in Coal in 2010 to that in 2012?
Provide a short and direct response. 1.07. What is the ratio of the Mineral Rent(as % of GDP) in Natural Gas in 2010 to that in 2012?
Offer a very short reply. 1.17. What is the ratio of the Mineral Rent(as % of GDP) of Oil in 2010 to that in 2012?
Your answer should be very brief. 0.8. What is the ratio of the Mineral Rent(as % of GDP) in Other Minerals in 2010 to that in 2012?
Your answer should be very brief. 0.92. What is the ratio of the Mineral Rent(as % of GDP) in Coal in 2010 to that in 2013?
Provide a short and direct response. 1.63. What is the ratio of the Mineral Rent(as % of GDP) in Natural Gas in 2010 to that in 2013?
Offer a very short reply. 1.2. What is the ratio of the Mineral Rent(as % of GDP) of Oil in 2010 to that in 2013?
Offer a terse response. 0.63. What is the ratio of the Mineral Rent(as % of GDP) of Other Minerals in 2010 to that in 2013?
Ensure brevity in your answer.  1.17. What is the ratio of the Mineral Rent(as % of GDP) of Coal in 2011 to that in 2012?
Provide a short and direct response. 1.52. What is the ratio of the Mineral Rent(as % of GDP) of Natural Gas in 2011 to that in 2012?
Your answer should be compact. 1.21. What is the ratio of the Mineral Rent(as % of GDP) of Oil in 2011 to that in 2012?
Your response must be concise. 0.88. What is the ratio of the Mineral Rent(as % of GDP) in Other Minerals in 2011 to that in 2012?
Your response must be concise. 1.12. What is the ratio of the Mineral Rent(as % of GDP) of Coal in 2011 to that in 2013?
Make the answer very short. 2.32. What is the ratio of the Mineral Rent(as % of GDP) in Natural Gas in 2011 to that in 2013?
Your answer should be compact. 1.23. What is the ratio of the Mineral Rent(as % of GDP) of Oil in 2011 to that in 2013?
Your answer should be compact. 0.69. What is the ratio of the Mineral Rent(as % of GDP) in Other Minerals in 2011 to that in 2013?
Your answer should be very brief. 1.41. What is the ratio of the Mineral Rent(as % of GDP) of Coal in 2012 to that in 2013?
Make the answer very short. 1.52. What is the ratio of the Mineral Rent(as % of GDP) of Natural Gas in 2012 to that in 2013?
Your response must be concise. 1.02. What is the ratio of the Mineral Rent(as % of GDP) in Oil in 2012 to that in 2013?
Give a very brief answer. 0.79. What is the ratio of the Mineral Rent(as % of GDP) of Other Minerals in 2012 to that in 2013?
Keep it short and to the point. 1.26. What is the difference between the highest and the second highest Mineral Rent(as % of GDP) in Coal?
Keep it short and to the point. 0.23. What is the difference between the highest and the second highest Mineral Rent(as % of GDP) in Natural Gas?
Ensure brevity in your answer.  0.13. What is the difference between the highest and the second highest Mineral Rent(as % of GDP) in Oil?
Your answer should be compact. 0.02. What is the difference between the highest and the second highest Mineral Rent(as % of GDP) in Other Minerals?
Your answer should be compact. 0.07. What is the difference between the highest and the lowest Mineral Rent(as % of GDP) of Coal?
Your answer should be compact. 0.82. What is the difference between the highest and the lowest Mineral Rent(as % of GDP) of Natural Gas?
Your answer should be compact. 0.17. What is the difference between the highest and the lowest Mineral Rent(as % of GDP) in Oil?
Give a very brief answer. 0.05. What is the difference between the highest and the lowest Mineral Rent(as % of GDP) in Other Minerals?
Provide a succinct answer. 0.29. 